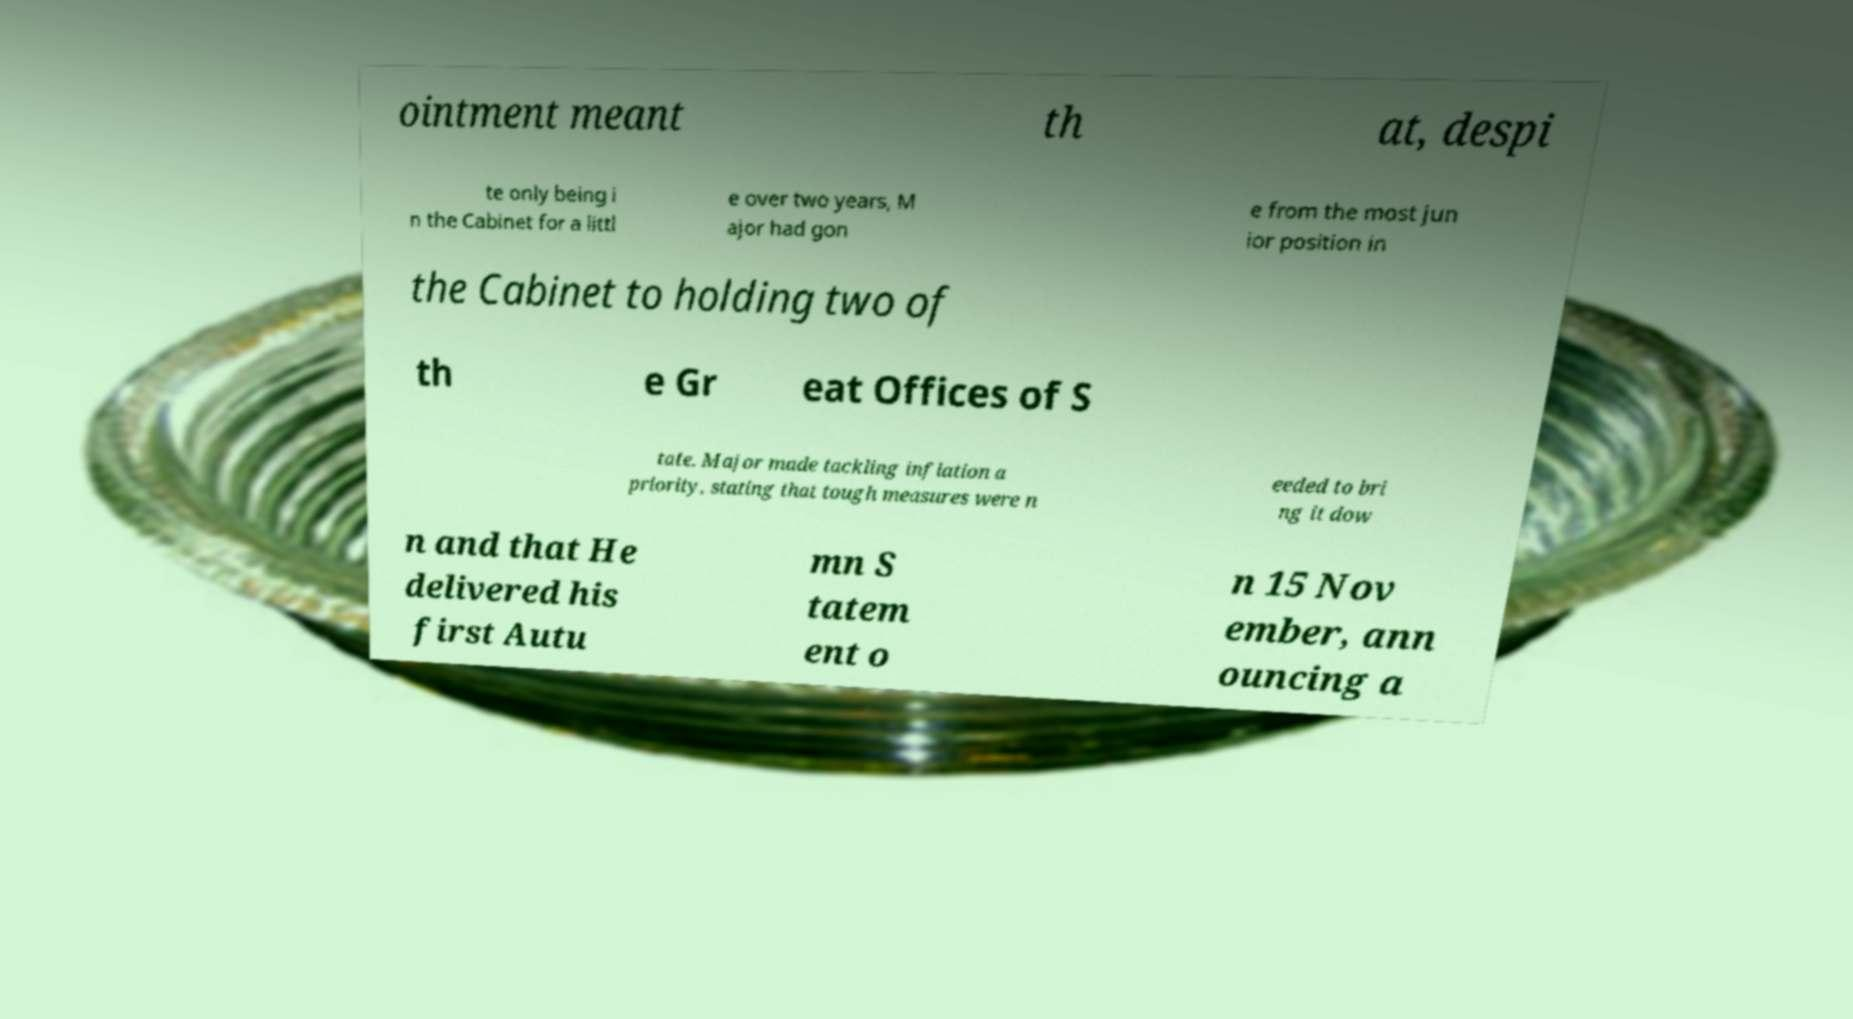For documentation purposes, I need the text within this image transcribed. Could you provide that? ointment meant th at, despi te only being i n the Cabinet for a littl e over two years, M ajor had gon e from the most jun ior position in the Cabinet to holding two of th e Gr eat Offices of S tate. Major made tackling inflation a priority, stating that tough measures were n eeded to bri ng it dow n and that He delivered his first Autu mn S tatem ent o n 15 Nov ember, ann ouncing a 